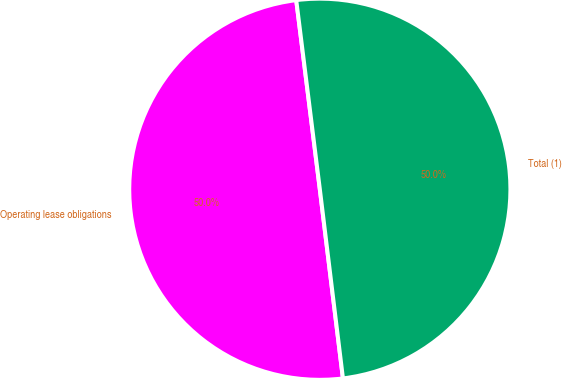Convert chart. <chart><loc_0><loc_0><loc_500><loc_500><pie_chart><fcel>Operating lease obligations<fcel>Total (1)<nl><fcel>49.96%<fcel>50.04%<nl></chart> 